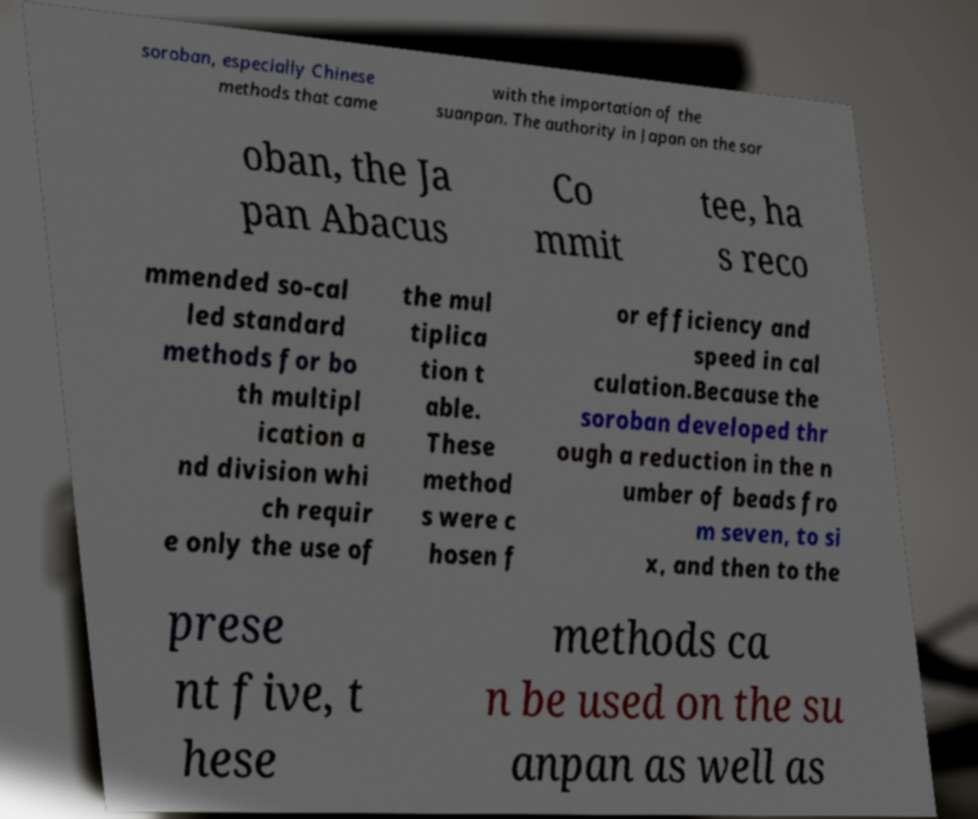Could you assist in decoding the text presented in this image and type it out clearly? soroban, especially Chinese methods that came with the importation of the suanpan. The authority in Japan on the sor oban, the Ja pan Abacus Co mmit tee, ha s reco mmended so-cal led standard methods for bo th multipl ication a nd division whi ch requir e only the use of the mul tiplica tion t able. These method s were c hosen f or efficiency and speed in cal culation.Because the soroban developed thr ough a reduction in the n umber of beads fro m seven, to si x, and then to the prese nt five, t hese methods ca n be used on the su anpan as well as 